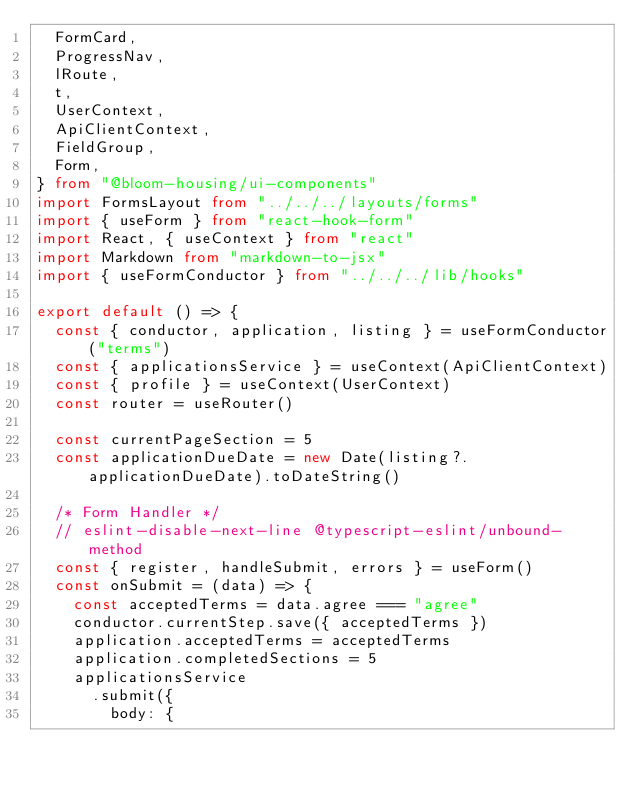Convert code to text. <code><loc_0><loc_0><loc_500><loc_500><_TypeScript_>  FormCard,
  ProgressNav,
  lRoute,
  t,
  UserContext,
  ApiClientContext,
  FieldGroup,
  Form,
} from "@bloom-housing/ui-components"
import FormsLayout from "../../../layouts/forms"
import { useForm } from "react-hook-form"
import React, { useContext } from "react"
import Markdown from "markdown-to-jsx"
import { useFormConductor } from "../../../lib/hooks"

export default () => {
  const { conductor, application, listing } = useFormConductor("terms")
  const { applicationsService } = useContext(ApiClientContext)
  const { profile } = useContext(UserContext)
  const router = useRouter()

  const currentPageSection = 5
  const applicationDueDate = new Date(listing?.applicationDueDate).toDateString()

  /* Form Handler */
  // eslint-disable-next-line @typescript-eslint/unbound-method
  const { register, handleSubmit, errors } = useForm()
  const onSubmit = (data) => {
    const acceptedTerms = data.agree === "agree"
    conductor.currentStep.save({ acceptedTerms })
    application.acceptedTerms = acceptedTerms
    application.completedSections = 5
    applicationsService
      .submit({
        body: {</code> 